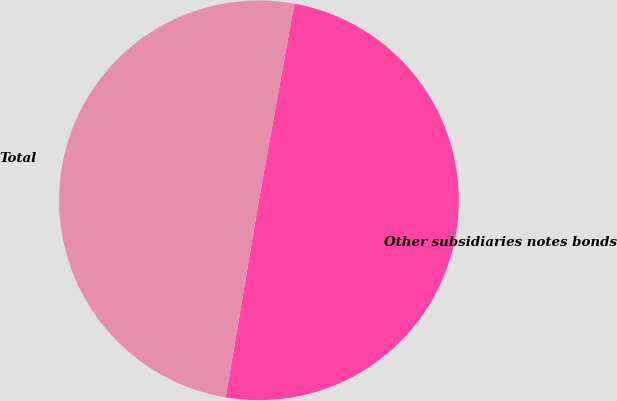<chart> <loc_0><loc_0><loc_500><loc_500><pie_chart><fcel>Other subsidiaries notes bonds<fcel>Total<nl><fcel>49.82%<fcel>50.18%<nl></chart> 